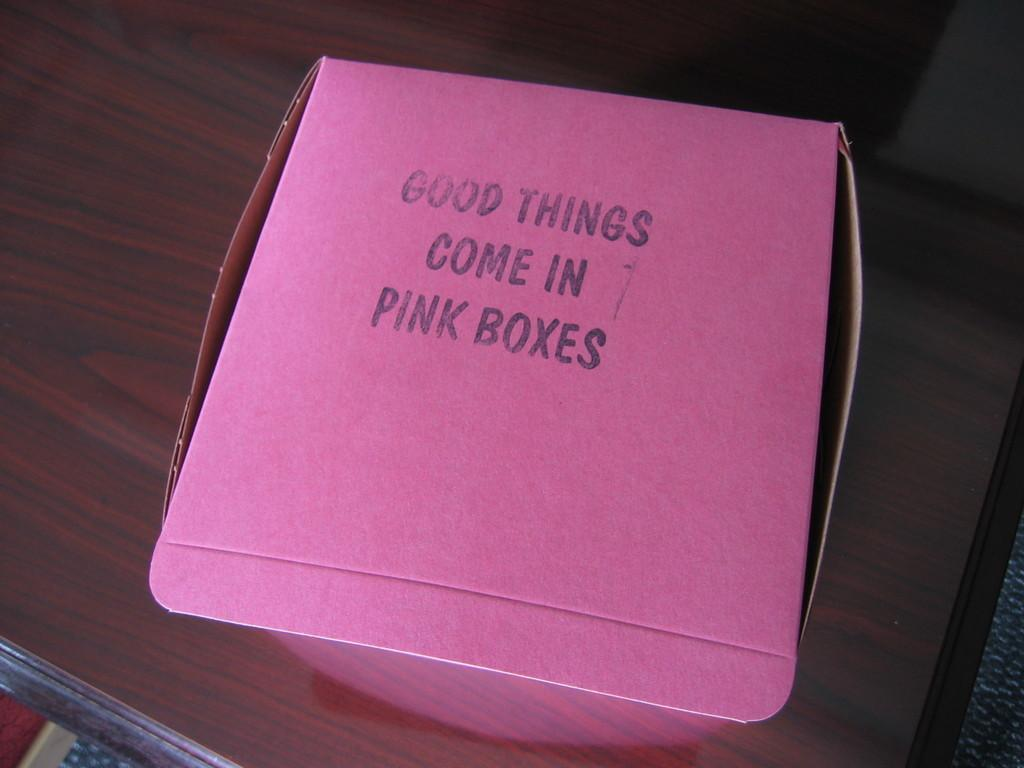Provide a one-sentence caption for the provided image. The pink box on the table probably contains something good. 